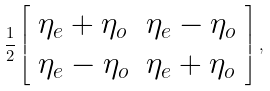<formula> <loc_0><loc_0><loc_500><loc_500>\frac { 1 } { 2 } \left [ \begin{array} { l l } \eta _ { e } + \eta _ { o } & \eta _ { e } - \eta _ { o } \\ \eta _ { e } - \eta _ { o } & \eta _ { e } + \eta _ { o } \end{array} \right ] ,</formula> 